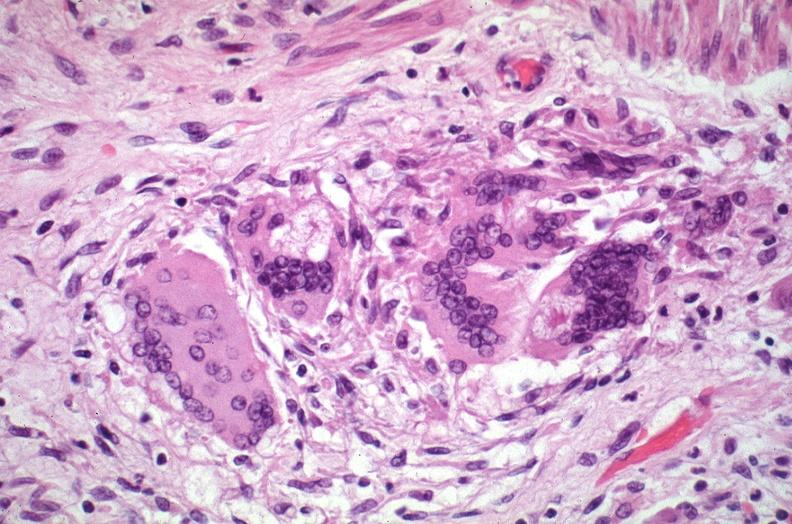what does this image show?
Answer the question using a single word or phrase. Lung 